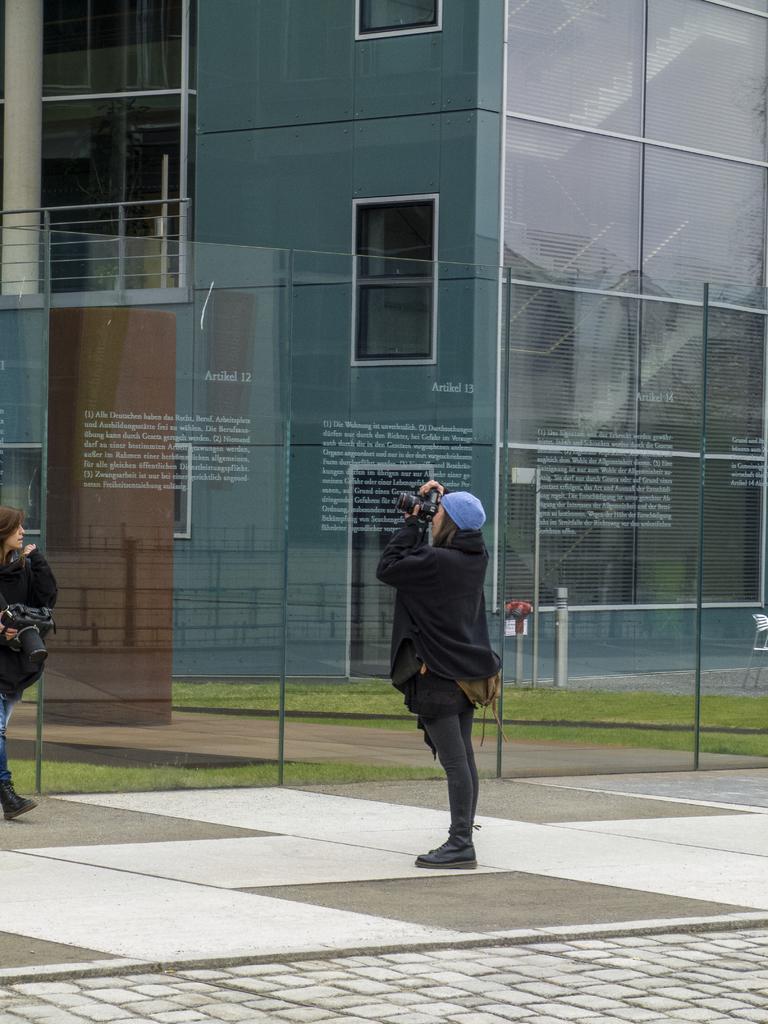How would you summarize this image in a sentence or two? A woman is holding camera, this is building with the windows. 